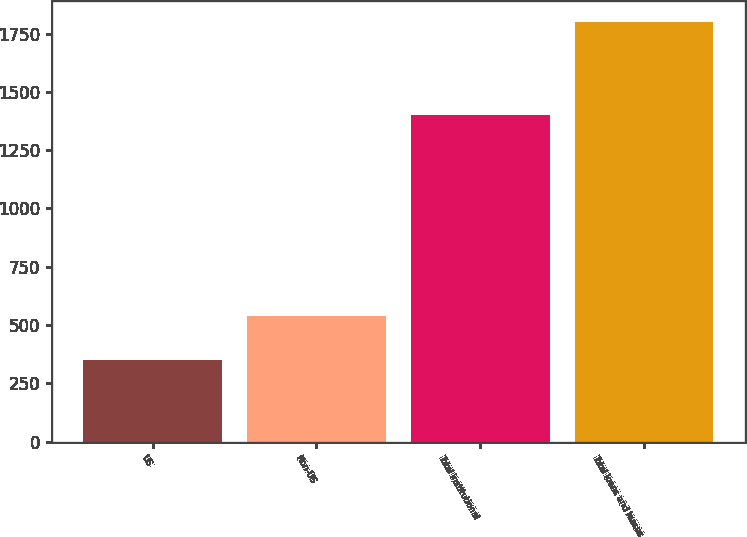Convert chart. <chart><loc_0><loc_0><loc_500><loc_500><bar_chart><fcel>US<fcel>Non-US<fcel>Total institutional<fcel>Total loans and leases<nl><fcel>349<fcel>540<fcel>1403<fcel>1801<nl></chart> 